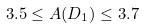Convert formula to latex. <formula><loc_0><loc_0><loc_500><loc_500>3 . 5 \leq A ( D _ { 1 } ) \leq 3 . 7</formula> 